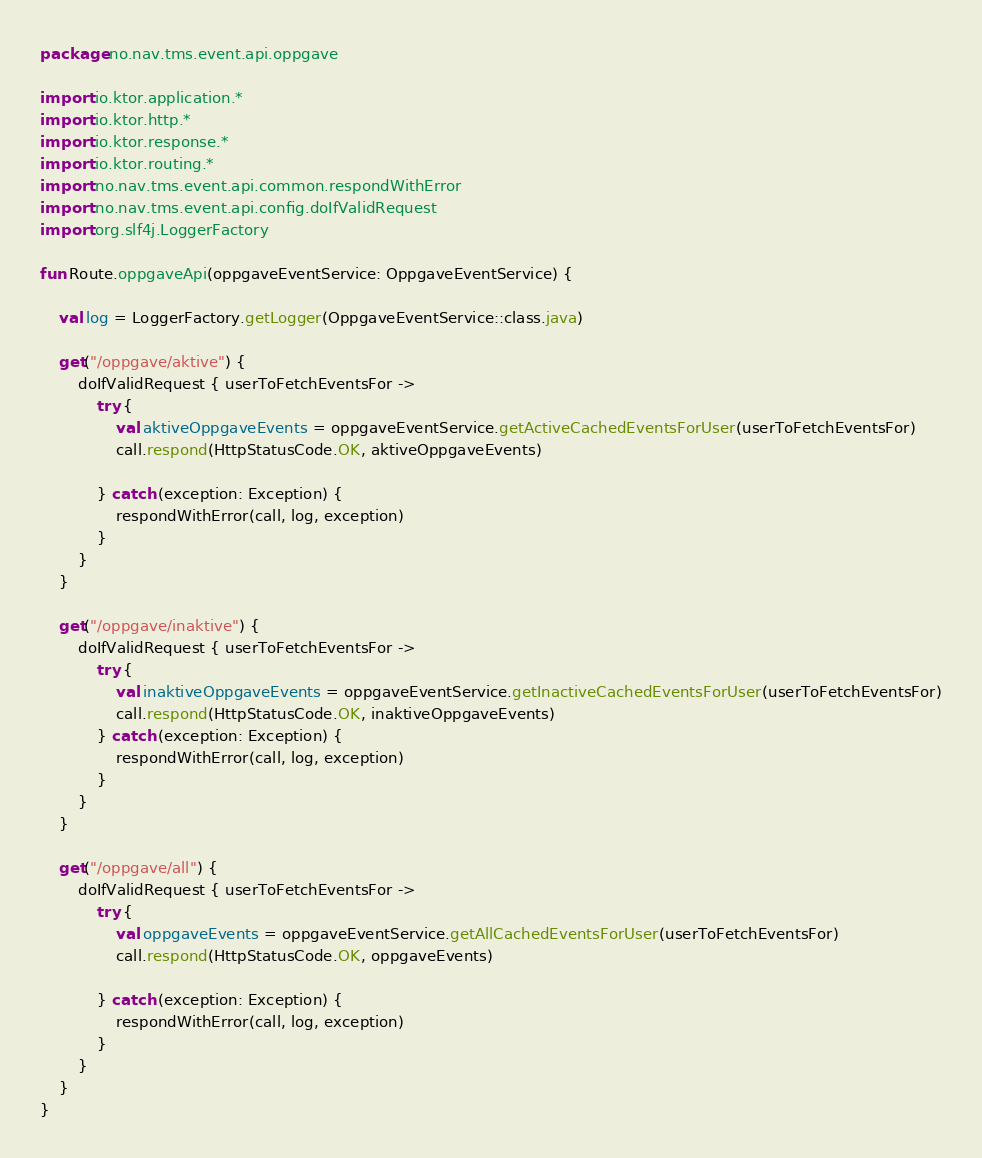Convert code to text. <code><loc_0><loc_0><loc_500><loc_500><_Kotlin_>package no.nav.tms.event.api.oppgave

import io.ktor.application.*
import io.ktor.http.*
import io.ktor.response.*
import io.ktor.routing.*
import no.nav.tms.event.api.common.respondWithError
import no.nav.tms.event.api.config.doIfValidRequest
import org.slf4j.LoggerFactory

fun Route.oppgaveApi(oppgaveEventService: OppgaveEventService) {

    val log = LoggerFactory.getLogger(OppgaveEventService::class.java)

    get("/oppgave/aktive") {
        doIfValidRequest { userToFetchEventsFor ->
            try {
                val aktiveOppgaveEvents = oppgaveEventService.getActiveCachedEventsForUser(userToFetchEventsFor)
                call.respond(HttpStatusCode.OK, aktiveOppgaveEvents)

            } catch (exception: Exception) {
                respondWithError(call, log, exception)
            }
        }
    }

    get("/oppgave/inaktive") {
        doIfValidRequest { userToFetchEventsFor ->
            try {
                val inaktiveOppgaveEvents = oppgaveEventService.getInactiveCachedEventsForUser(userToFetchEventsFor)
                call.respond(HttpStatusCode.OK, inaktiveOppgaveEvents)
            } catch (exception: Exception) {
                respondWithError(call, log, exception)
            }
        }
    }

    get("/oppgave/all") {
        doIfValidRequest { userToFetchEventsFor ->
            try {
                val oppgaveEvents = oppgaveEventService.getAllCachedEventsForUser(userToFetchEventsFor)
                call.respond(HttpStatusCode.OK, oppgaveEvents)

            } catch (exception: Exception) {
                respondWithError(call, log, exception)
            }
        }
    }
}
</code> 